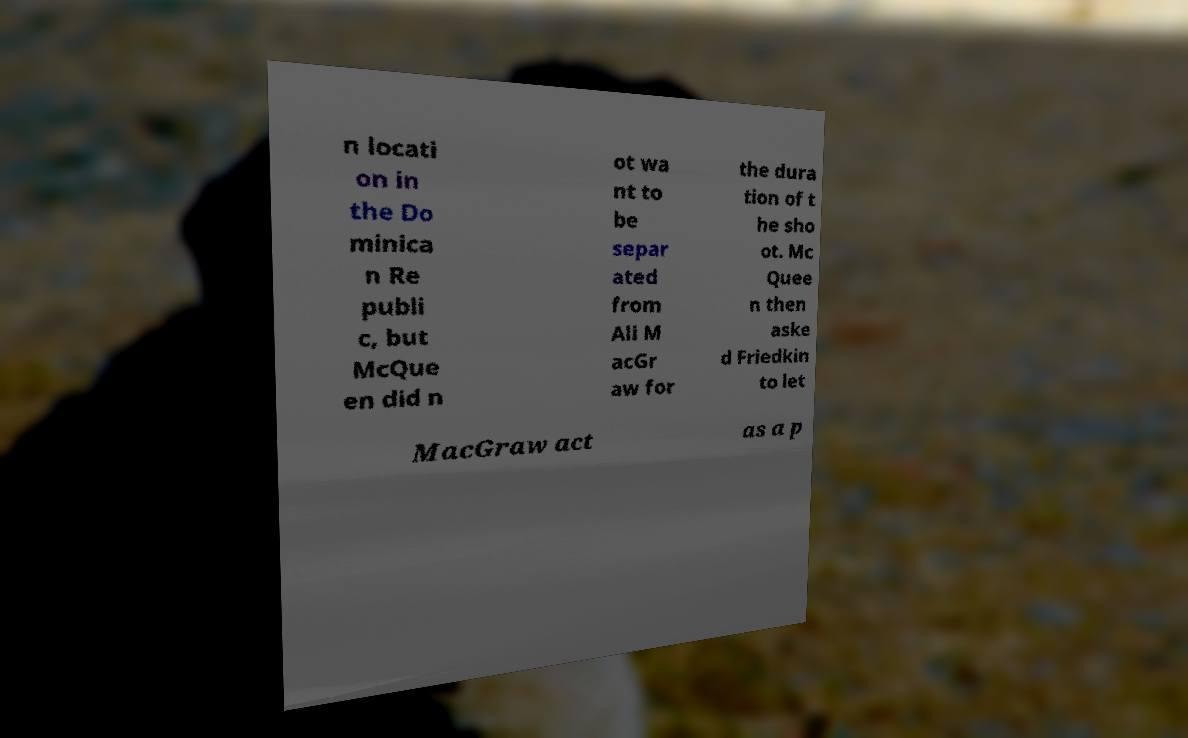I need the written content from this picture converted into text. Can you do that? n locati on in the Do minica n Re publi c, but McQue en did n ot wa nt to be separ ated from Ali M acGr aw for the dura tion of t he sho ot. Mc Quee n then aske d Friedkin to let MacGraw act as a p 